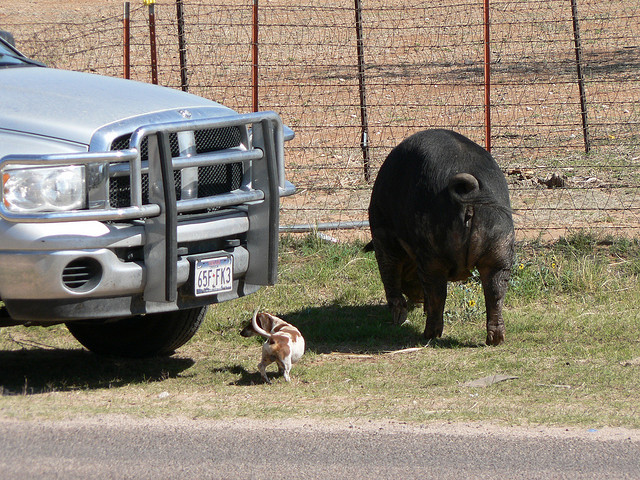Extract all visible text content from this image. 65F FK3 